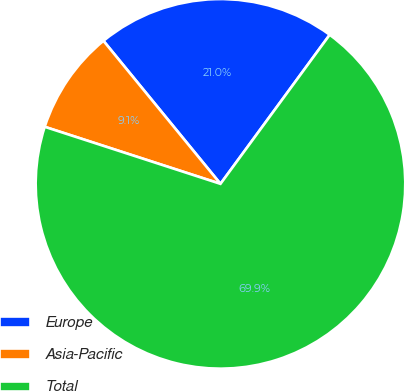Convert chart to OTSL. <chart><loc_0><loc_0><loc_500><loc_500><pie_chart><fcel>Europe<fcel>Asia-Pacific<fcel>Total<nl><fcel>20.98%<fcel>9.09%<fcel>69.93%<nl></chart> 